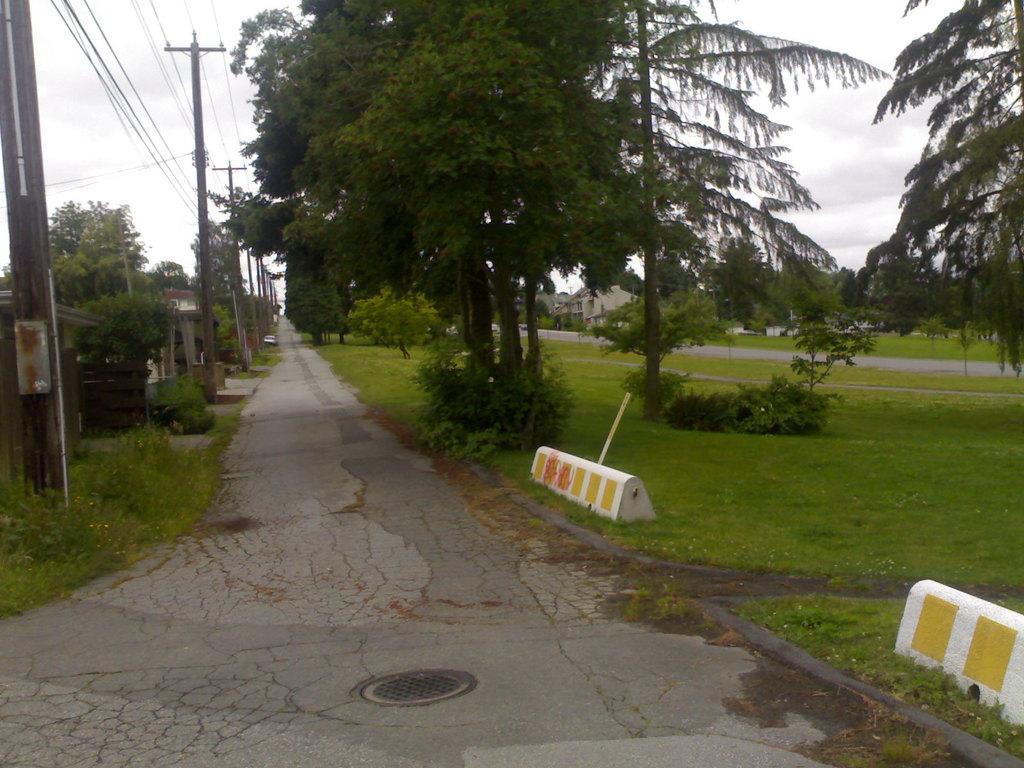How would you summarize this image in a sentence or two? There is a walkway. There are electric poles and wires at the left. There are trees and buildings on the either sides of the walkway. 